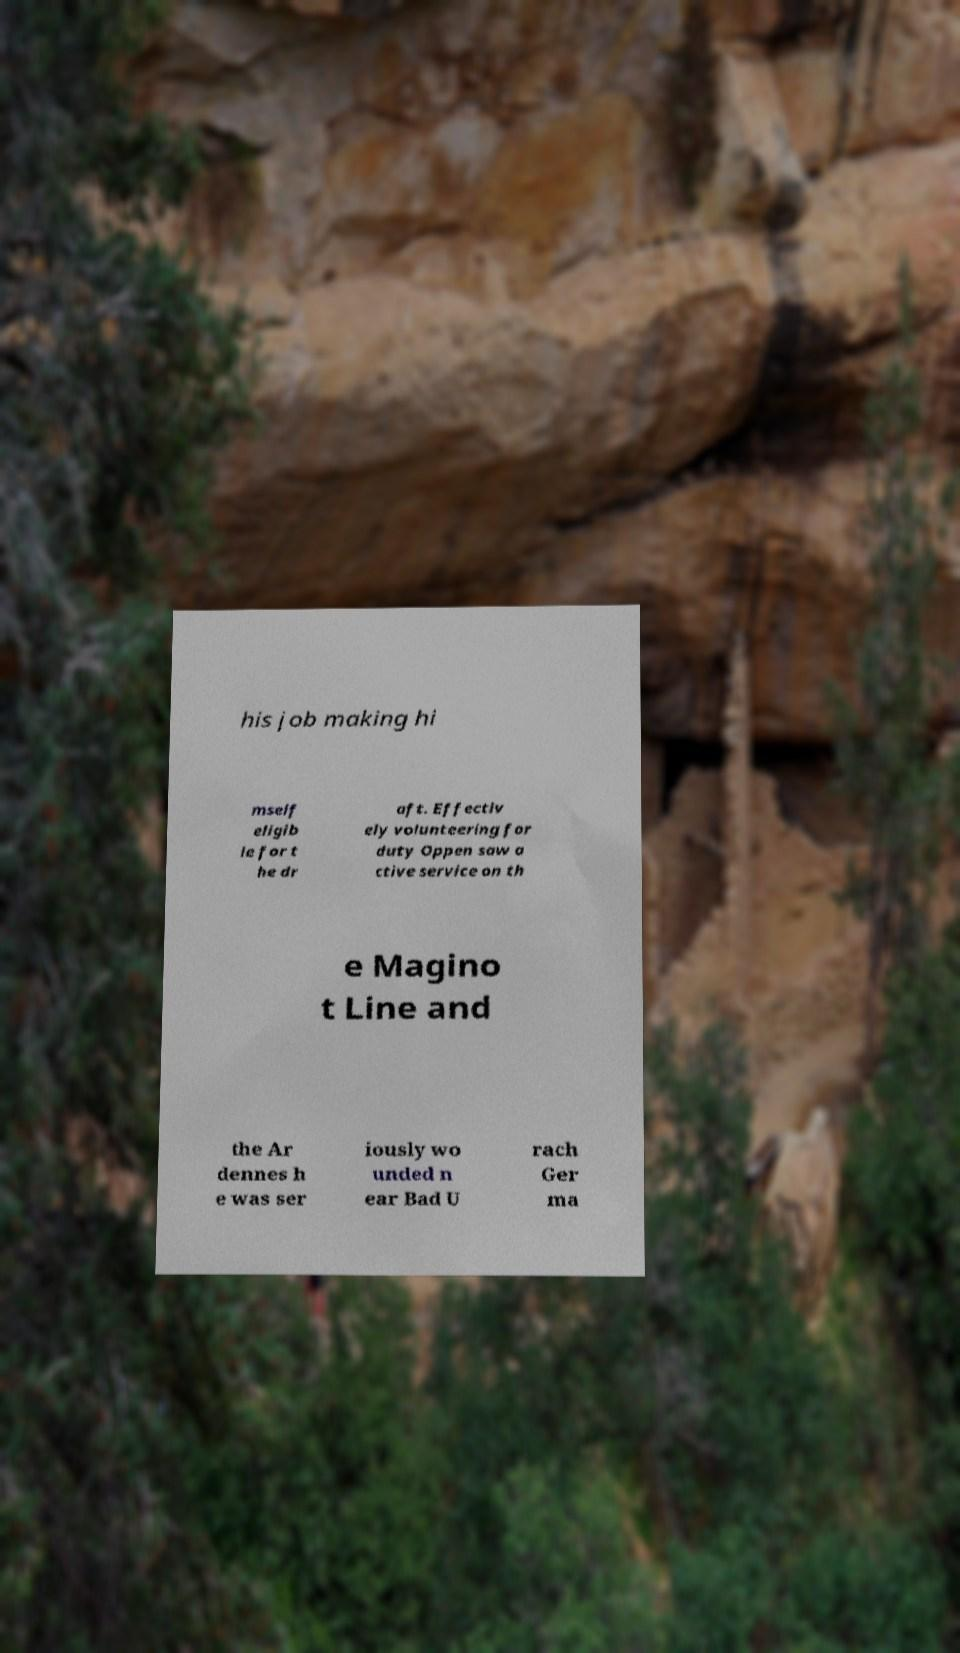Can you read and provide the text displayed in the image?This photo seems to have some interesting text. Can you extract and type it out for me? his job making hi mself eligib le for t he dr aft. Effectiv ely volunteering for duty Oppen saw a ctive service on th e Magino t Line and the Ar dennes h e was ser iously wo unded n ear Bad U rach Ger ma 